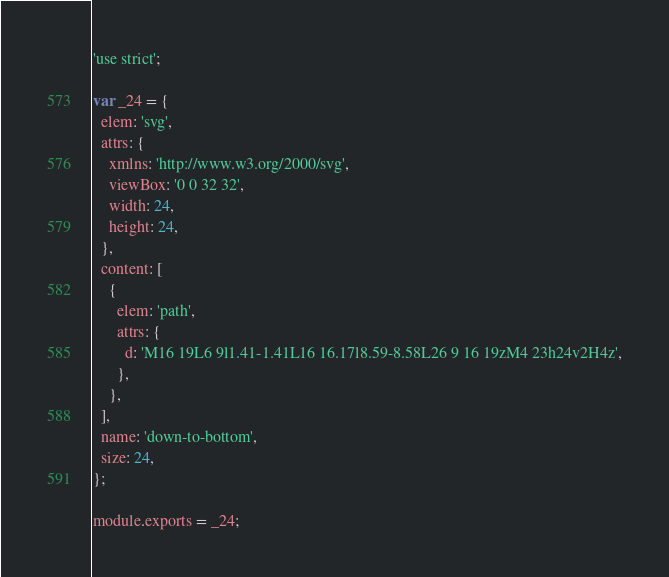Convert code to text. <code><loc_0><loc_0><loc_500><loc_500><_JavaScript_>'use strict';

var _24 = {
  elem: 'svg',
  attrs: {
    xmlns: 'http://www.w3.org/2000/svg',
    viewBox: '0 0 32 32',
    width: 24,
    height: 24,
  },
  content: [
    {
      elem: 'path',
      attrs: {
        d: 'M16 19L6 9l1.41-1.41L16 16.17l8.59-8.58L26 9 16 19zM4 23h24v2H4z',
      },
    },
  ],
  name: 'down-to-bottom',
  size: 24,
};

module.exports = _24;
</code> 